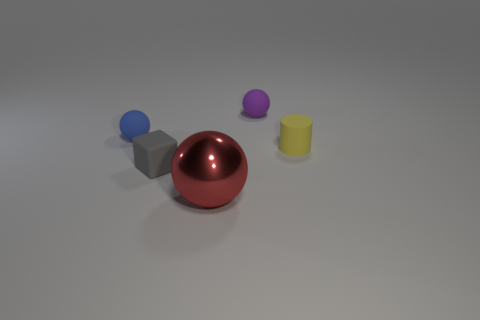Subtract all small balls. How many balls are left? 1 Add 4 tiny blue spheres. How many objects exist? 9 Subtract all red balls. How many balls are left? 2 Subtract all cylinders. How many objects are left? 4 Subtract 1 balls. How many balls are left? 2 Subtract 0 purple cubes. How many objects are left? 5 Subtract all brown cylinders. Subtract all blue cubes. How many cylinders are left? 1 Subtract all brown cylinders. How many red balls are left? 1 Subtract all tiny matte blocks. Subtract all large red balls. How many objects are left? 3 Add 5 small yellow matte things. How many small yellow matte things are left? 6 